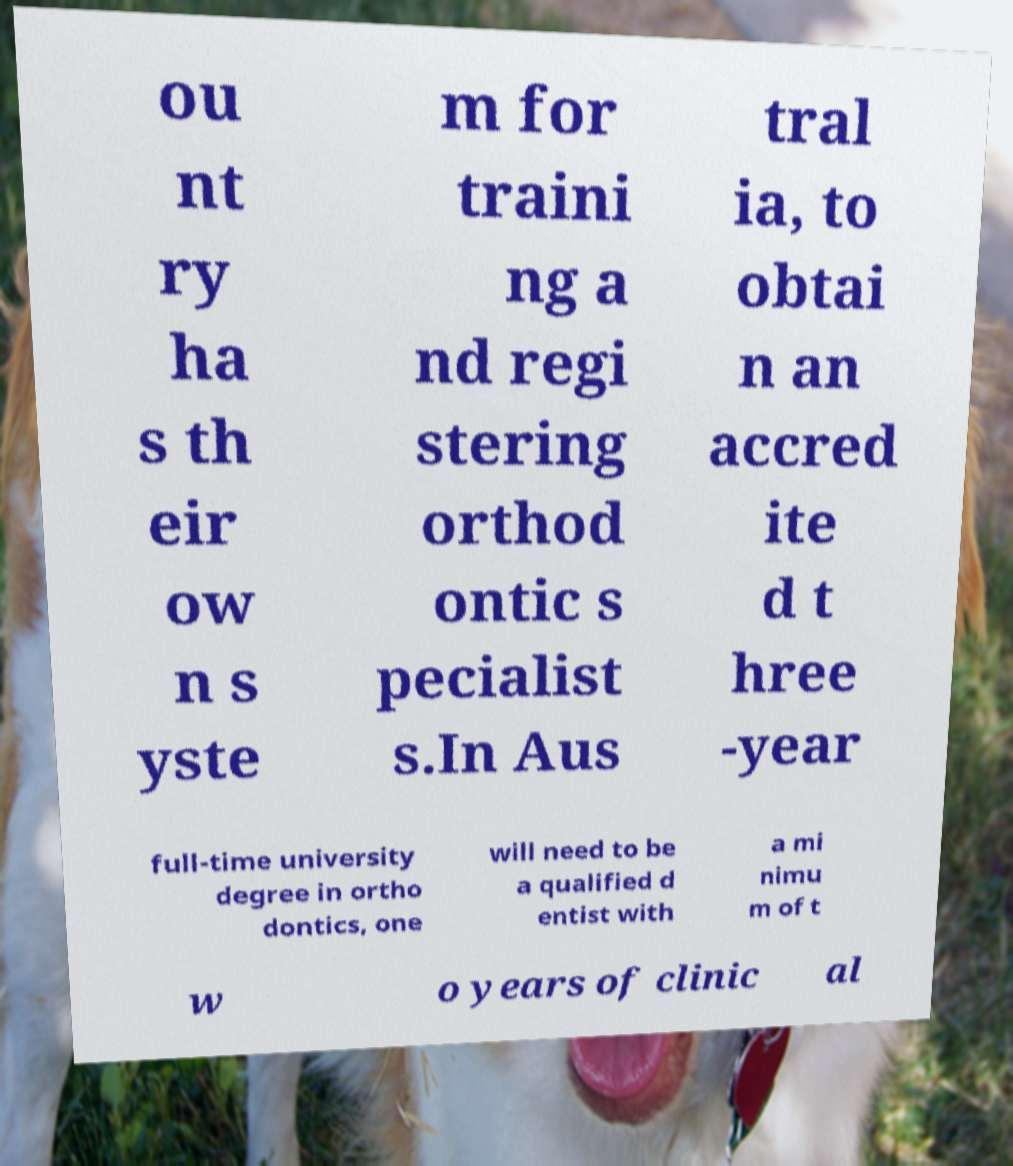What messages or text are displayed in this image? I need them in a readable, typed format. ou nt ry ha s th eir ow n s yste m for traini ng a nd regi stering orthod ontic s pecialist s.In Aus tral ia, to obtai n an accred ite d t hree -year full-time university degree in ortho dontics, one will need to be a qualified d entist with a mi nimu m of t w o years of clinic al 